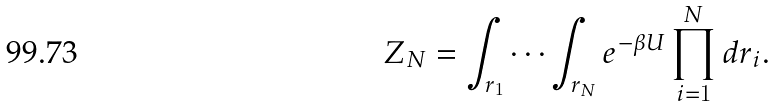<formula> <loc_0><loc_0><loc_500><loc_500>Z _ { N } = \int _ { r _ { 1 } } \cdots \int _ { r _ { N } } e ^ { - \beta U } \prod _ { i = 1 } ^ { N } d r _ { i } .</formula> 